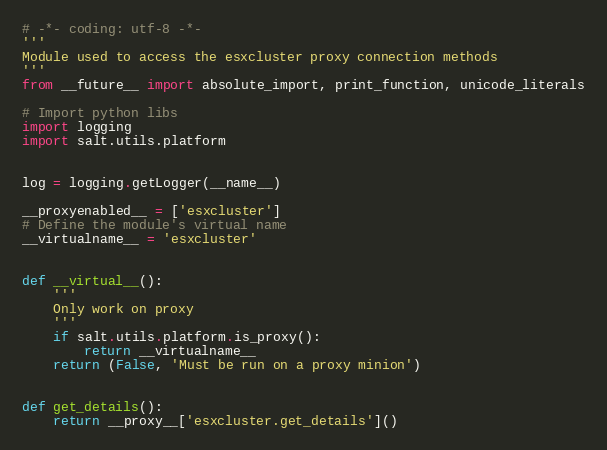Convert code to text. <code><loc_0><loc_0><loc_500><loc_500><_Python_># -*- coding: utf-8 -*-
'''
Module used to access the esxcluster proxy connection methods
'''
from __future__ import absolute_import, print_function, unicode_literals

# Import python libs
import logging
import salt.utils.platform


log = logging.getLogger(__name__)

__proxyenabled__ = ['esxcluster']
# Define the module's virtual name
__virtualname__ = 'esxcluster'


def __virtual__():
    '''
    Only work on proxy
    '''
    if salt.utils.platform.is_proxy():
        return __virtualname__
    return (False, 'Must be run on a proxy minion')


def get_details():
    return __proxy__['esxcluster.get_details']()
</code> 